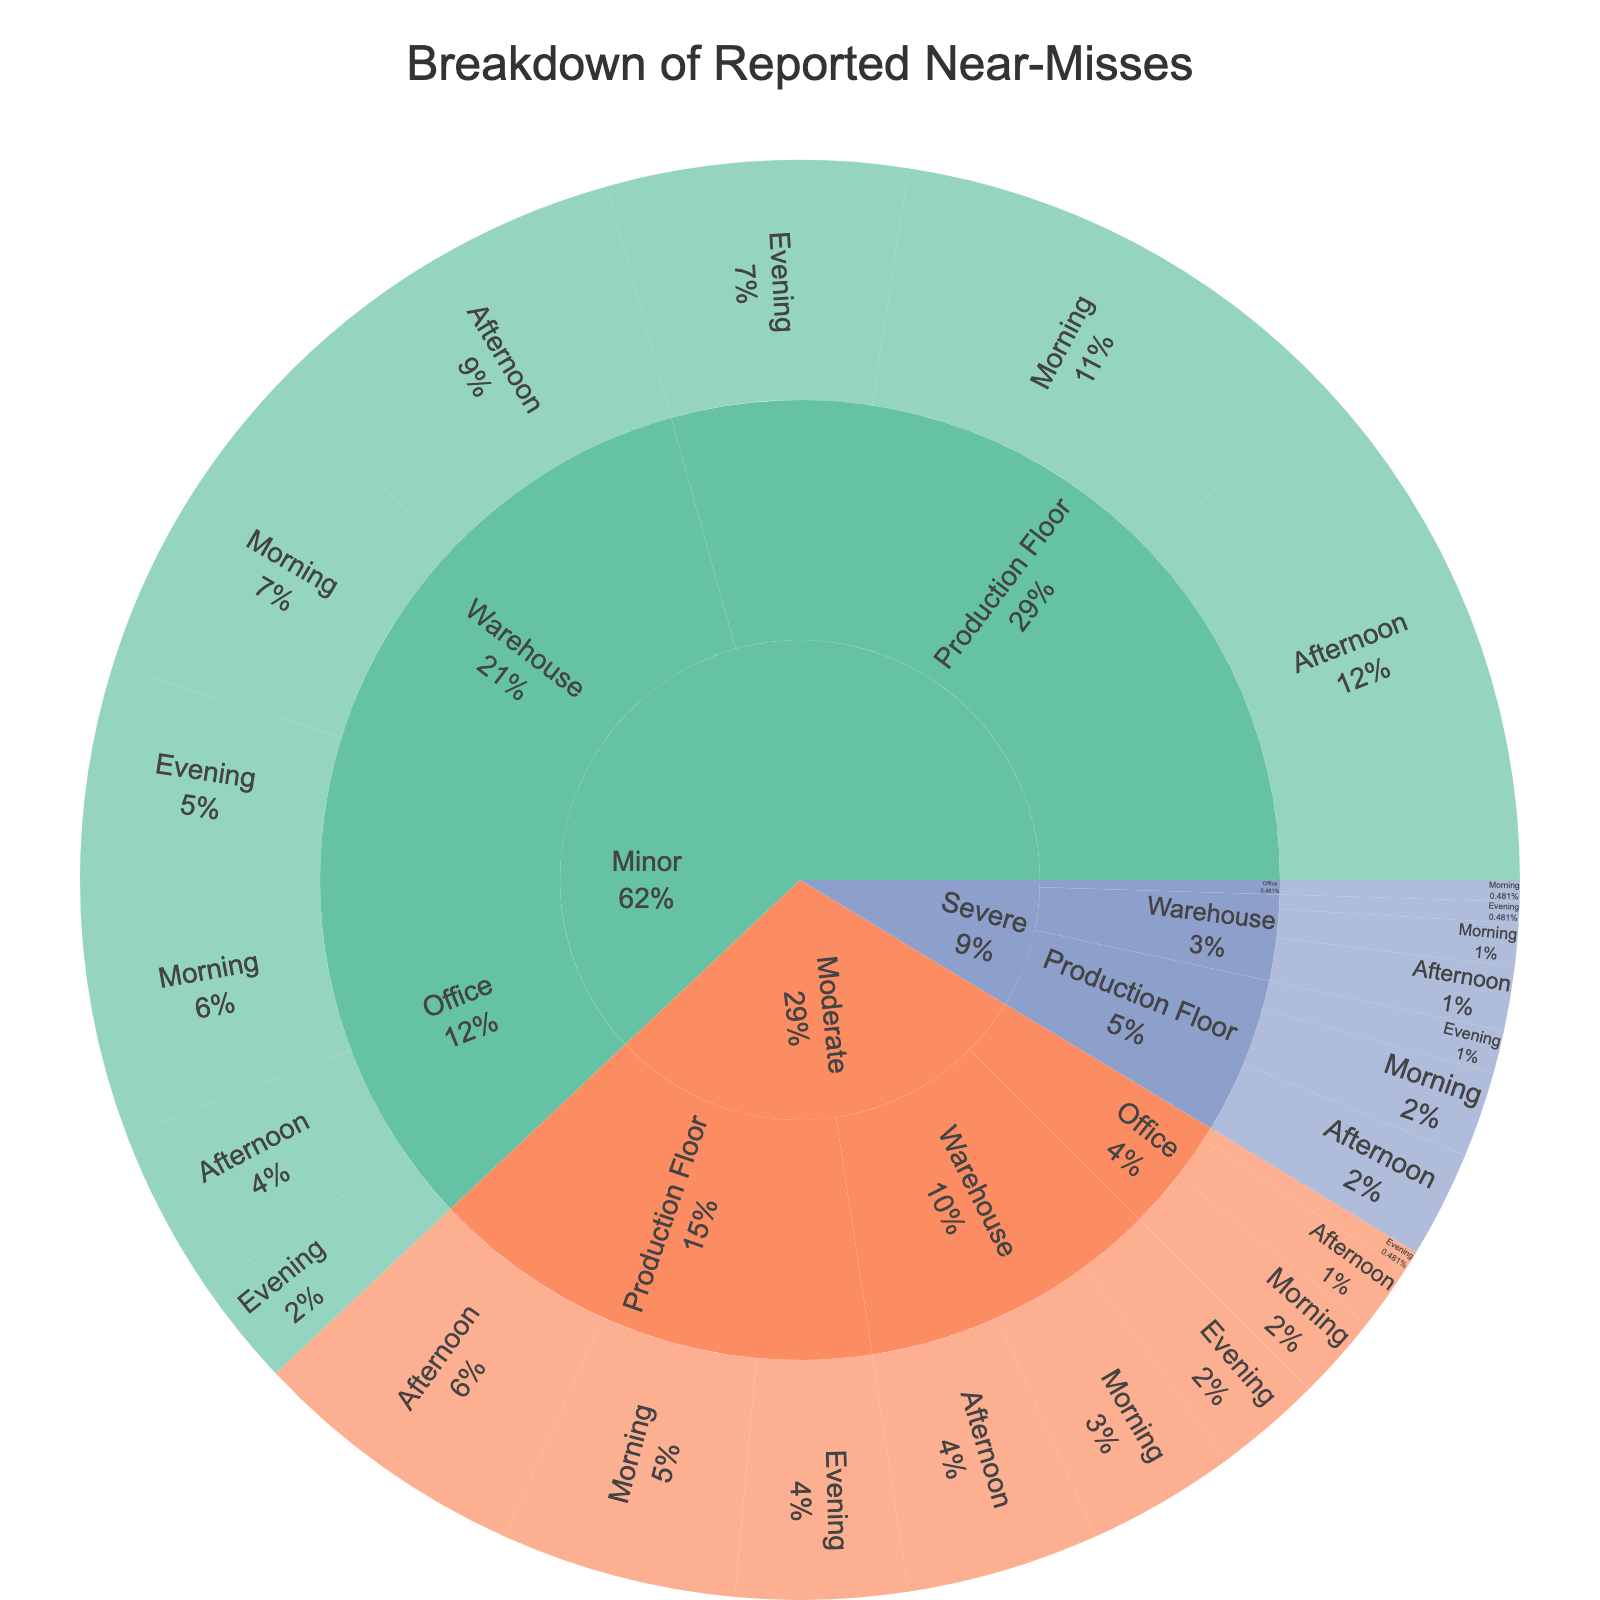What is the title of the Sunburst Plot? The title is usually found at the top of the figure. Simply read the text displayed as the title.
Answer: Breakdown of Reported Near-Misses What percentage of near-misses occurred in the Office location during the Morning time? Find the slice representing "Office" and then look for the segment "Morning" within it; read the percentage displayed.
Answer: 4.2% Which severity level has the highest number of reported near-misses? Compare the total counts for all severity levels. The severity with the largest slice and value is the answer.
Answer: Minor How many near-misses occurred in the Warehouse during the Afternoon time across all severity levels? Sum the counts for Minor, Moderate, and Severe near-misses in the Warehouse during the Afternoon.
Answer: 30 What is the color assigned to the "Moderate" severity level? Identify the slice labeled "Moderate" and note its color.
Answer: Orange Compare the number of near-misses in the Production Floor during the Evening with those in the Warehouse during the Evening. Which one is higher? Locate the "Evening" slices for both "Production Floor" and "Warehouse," and compare their values.
Answer: Production Floor How many more near-misses were reported in the Morning than in the Evening across all locations? Sum the near-misses for Morning and Evening across all locations and find the difference.
Answer: 51 - 33 = 18 What's the average number of near-misses reported during the Afternoon across all locations and severity levels? Sum the near-misses during the Afternoon across all locations and severity levels and then divide by the number of data points.
Answer: (8 + 18 + 25 + 3 + 9 + 13 + 0 + 3 + 5) / 9 = 84 / 9 ≈ 9.33 Which location recorded the highest number of Severe near-misses? Compare the counts of Severe near-misses across all locations and identify the highest value.
Answer: Production Floor 